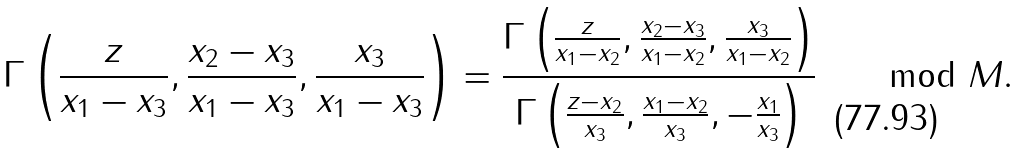Convert formula to latex. <formula><loc_0><loc_0><loc_500><loc_500>\Gamma \left ( \frac { z } { x _ { 1 } - x _ { 3 } } , \frac { x _ { 2 } - x _ { 3 } } { x _ { 1 } - x _ { 3 } } , \frac { x _ { 3 } } { x _ { 1 } - x _ { 3 } } \right ) = \frac { \Gamma \left ( \frac { z } { x _ { 1 } - x _ { 2 } } , \frac { x _ { 2 } - x _ { 3 } } { x _ { 1 } - x _ { 2 } } , \frac { x _ { 3 } } { x _ { 1 } - x _ { 2 } } \right ) } { \Gamma \left ( \frac { z - x _ { 2 } } { x _ { 3 } } , \frac { x _ { 1 } - x _ { 2 } } { x _ { 3 } } , - \frac { x _ { 1 } } { x _ { 3 } } \right ) } \quad \mod M .</formula> 